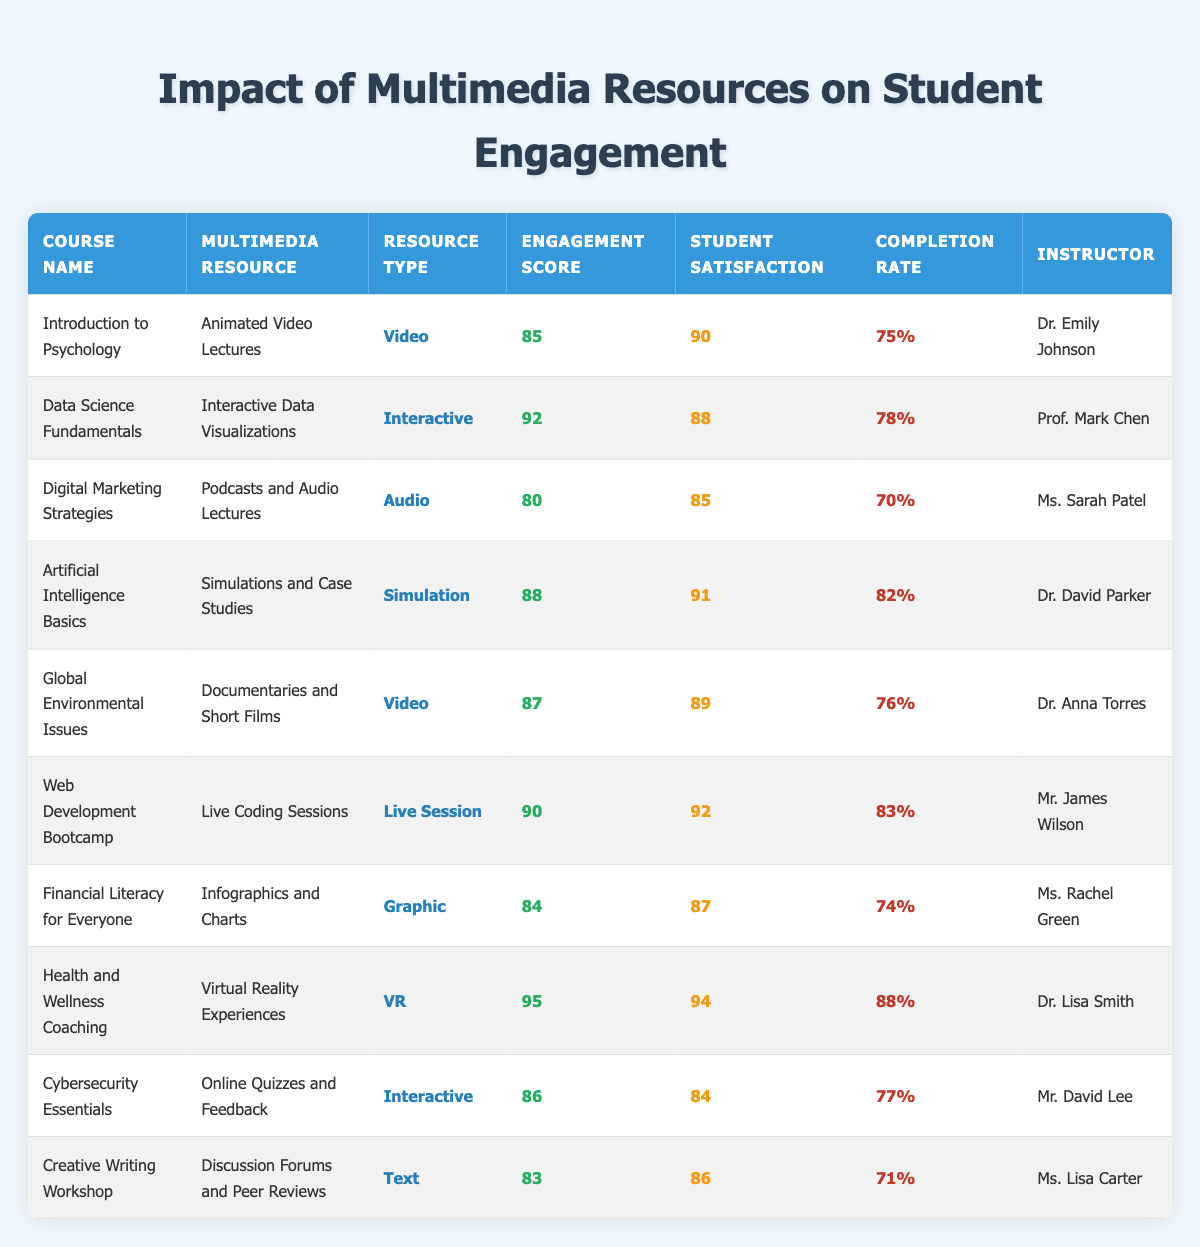What is the engagement score for the course "Health and Wellness Coaching"? Referring to the table, the engagement score for "Health and Wellness Coaching" is listed as 95.
Answer: 95 Which instructor teaches "Digital Marketing Strategies"? The table indicates that "Digital Marketing Strategies" is taught by Ms. Sarah Patel.
Answer: Ms. Sarah Patel What is the completion rate for the course with the highest engagement score? The course with the highest engagement score is "Health and Wellness Coaching" with a score of 95, and its completion rate is 88%.
Answer: 88% Which multimedia resource is associated with the course "Data Science Fundamentals"? The table shows that "Data Science Fundamentals" uses "Interactive Data Visualizations" as its multimedia resource.
Answer: Interactive Data Visualizations What is the average engagement score of all courses listed? To find the average engagement score, sum all the engagement scores: (85 + 92 + 80 + 88 + 87 + 90 + 84 + 95 + 86 + 83) =  885. There are 10 courses, so the average is 885/10 = 88.5.
Answer: 88.5 Is the student satisfaction score for "Cybersecurity Essentials" above 80? The student satisfaction score for "Cybersecurity Essentials" is 84, which is above 80.
Answer: Yes Which course has a completion rate lower than 75%? Referring to the table, "Digital Marketing Strategies" has a completion rate of 70%, which is lower than 75%.
Answer: Digital Marketing Strategies How does the engagement score of "Introduction to Psychology" compare to the engagement score of "Creative Writing Workshop"? "Introduction to Psychology" has an engagement score of 85, while "Creative Writing Workshop" has an engagement score of 83. Thus, the score for "Introduction to Psychology" is higher by 2 points: 85 - 83 = 2.
Answer: Higher by 2 points What multimedia resource is common among courses that have an engagement score above 85? The courses with an engagement score above 85 are: "Health and Wellness Coaching" (VR), "Data Science Fundamentals" (Interactive), "Artificial Intelligence Basics" (Simulation), "Web Development Bootcamp" (Live Session), and "Global Environmental Issues" (Video). The common multimedia resource type in this case is "Video" used in "Global Environmental Issues", while the other types differ.
Answer: Video is common in one course 